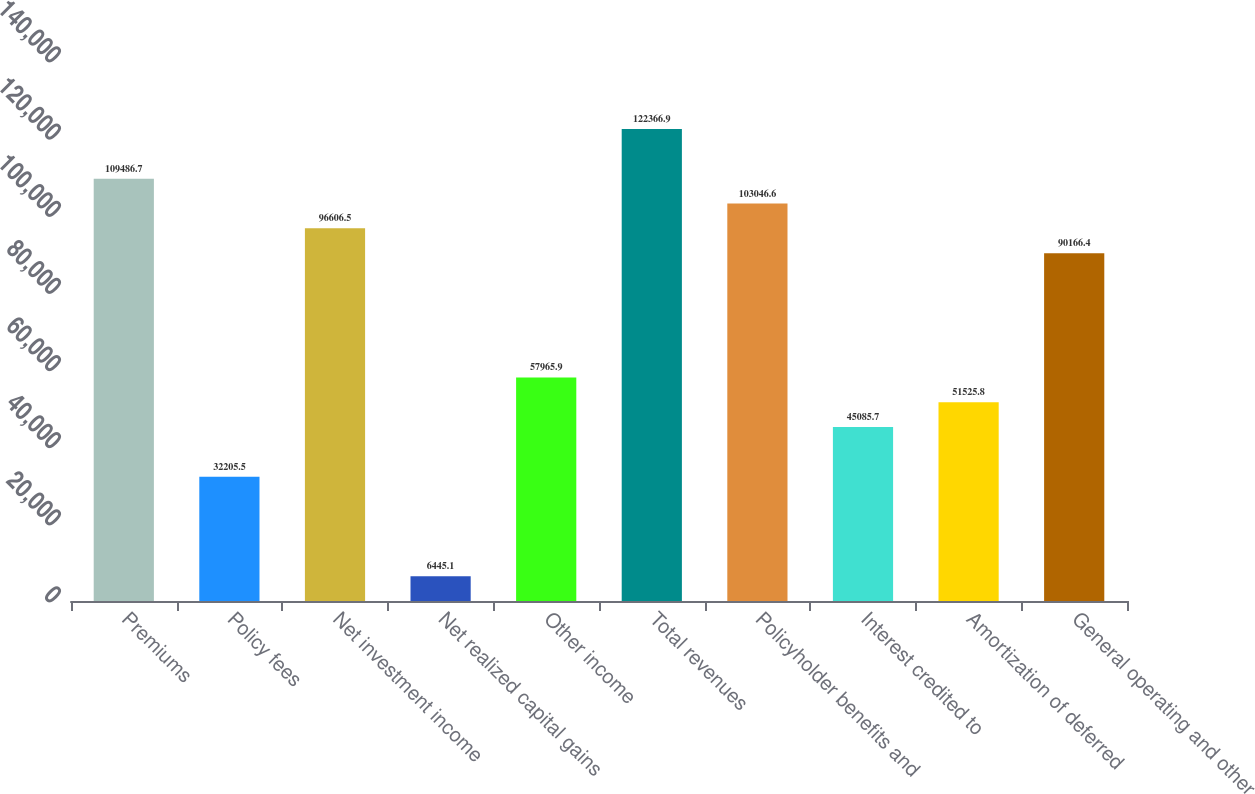Convert chart to OTSL. <chart><loc_0><loc_0><loc_500><loc_500><bar_chart><fcel>Premiums<fcel>Policy fees<fcel>Net investment income<fcel>Net realized capital gains<fcel>Other income<fcel>Total revenues<fcel>Policyholder benefits and<fcel>Interest credited to<fcel>Amortization of deferred<fcel>General operating and other<nl><fcel>109487<fcel>32205.5<fcel>96606.5<fcel>6445.1<fcel>57965.9<fcel>122367<fcel>103047<fcel>45085.7<fcel>51525.8<fcel>90166.4<nl></chart> 